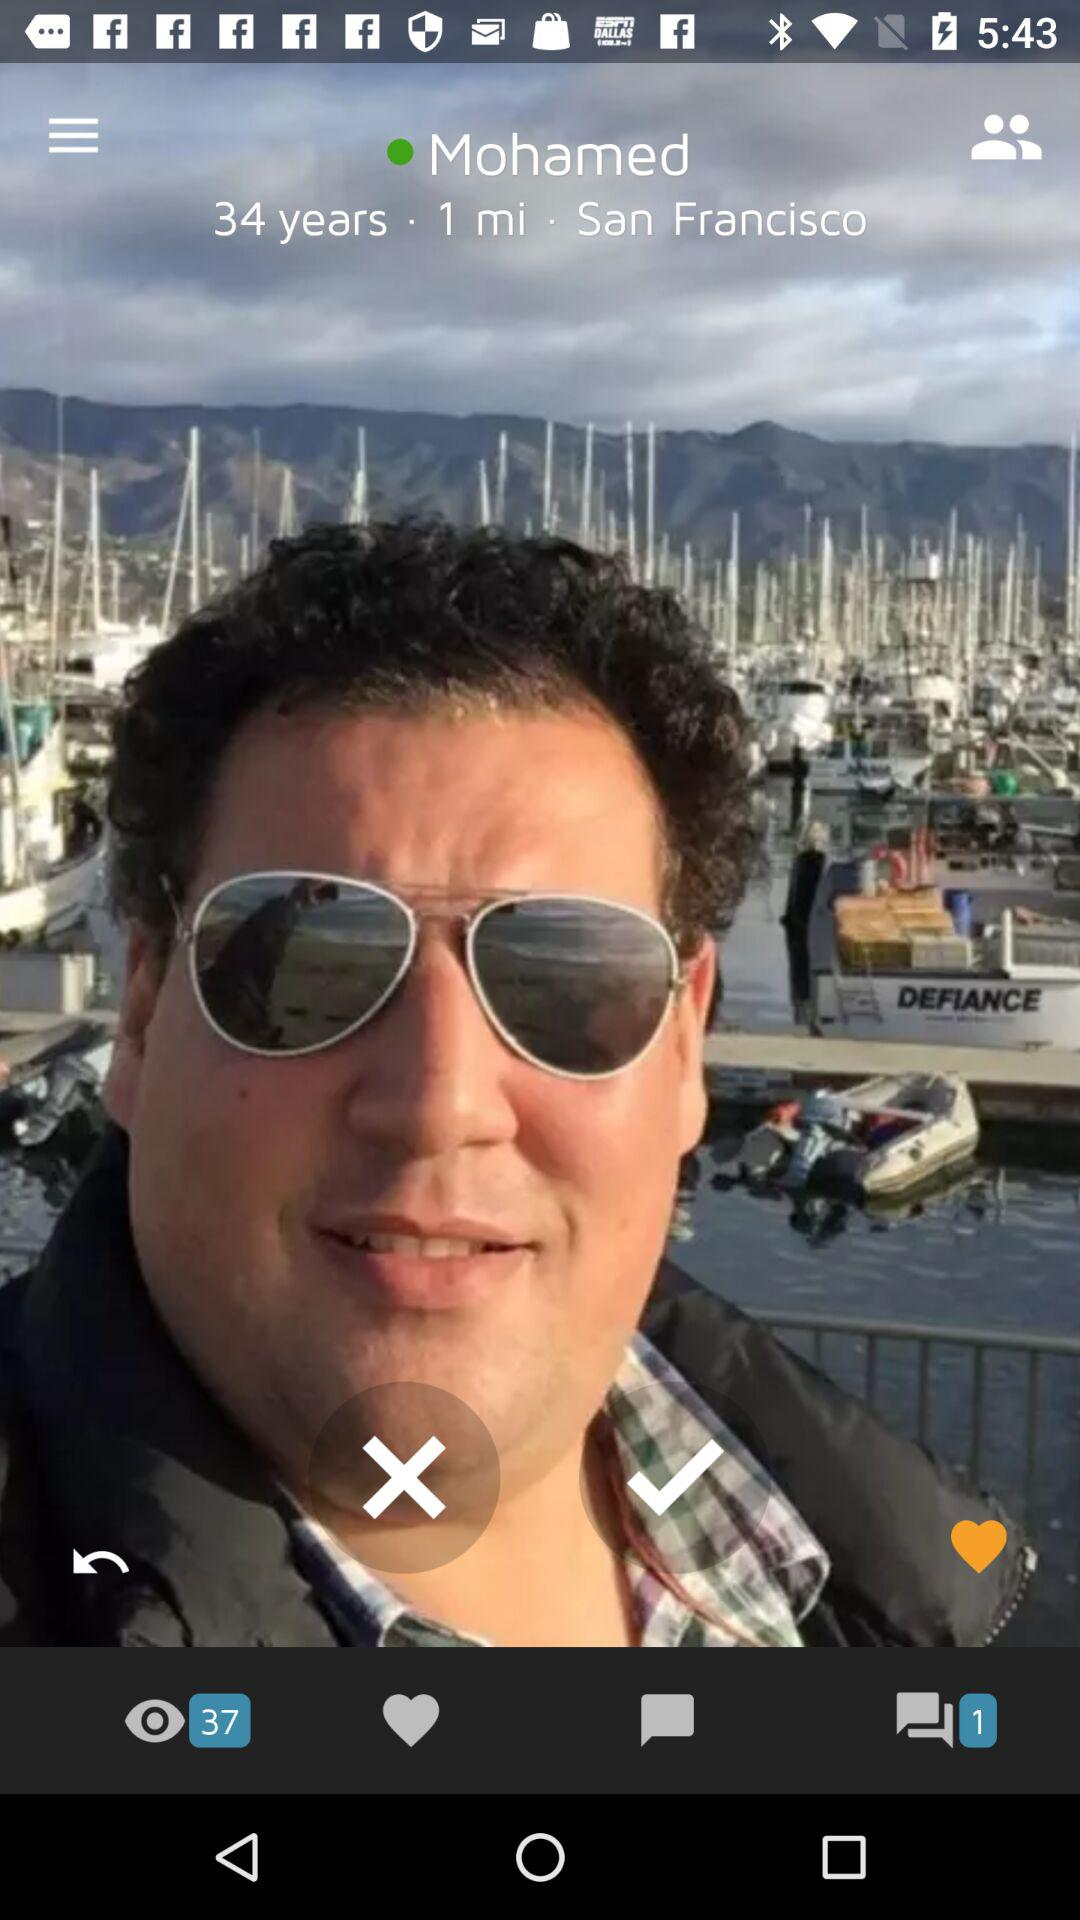How many views are there? There are 37 views. 